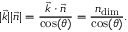Convert formula to latex. <formula><loc_0><loc_0><loc_500><loc_500>| \vec { k } | | \vec { n } | = \frac { \vec { k } \cdot \vec { n } } { \cos ( \theta ) } = \frac { n _ { d i m } } { \cos ( \theta ) } .</formula> 